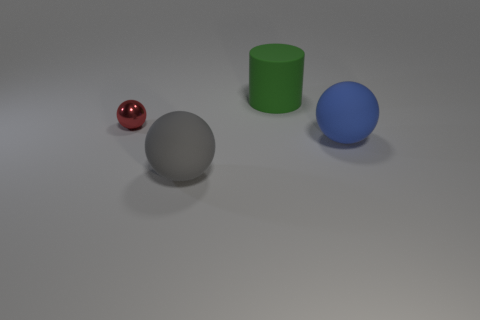Subtract all blue balls. How many balls are left? 2 Add 3 large rubber objects. How many objects exist? 7 Subtract all brown spheres. Subtract all purple cylinders. How many spheres are left? 3 Subtract all balls. How many objects are left? 1 Subtract all small yellow objects. Subtract all small red metallic balls. How many objects are left? 3 Add 4 large blue balls. How many large blue balls are left? 5 Add 2 metallic objects. How many metallic objects exist? 3 Subtract 0 blue blocks. How many objects are left? 4 